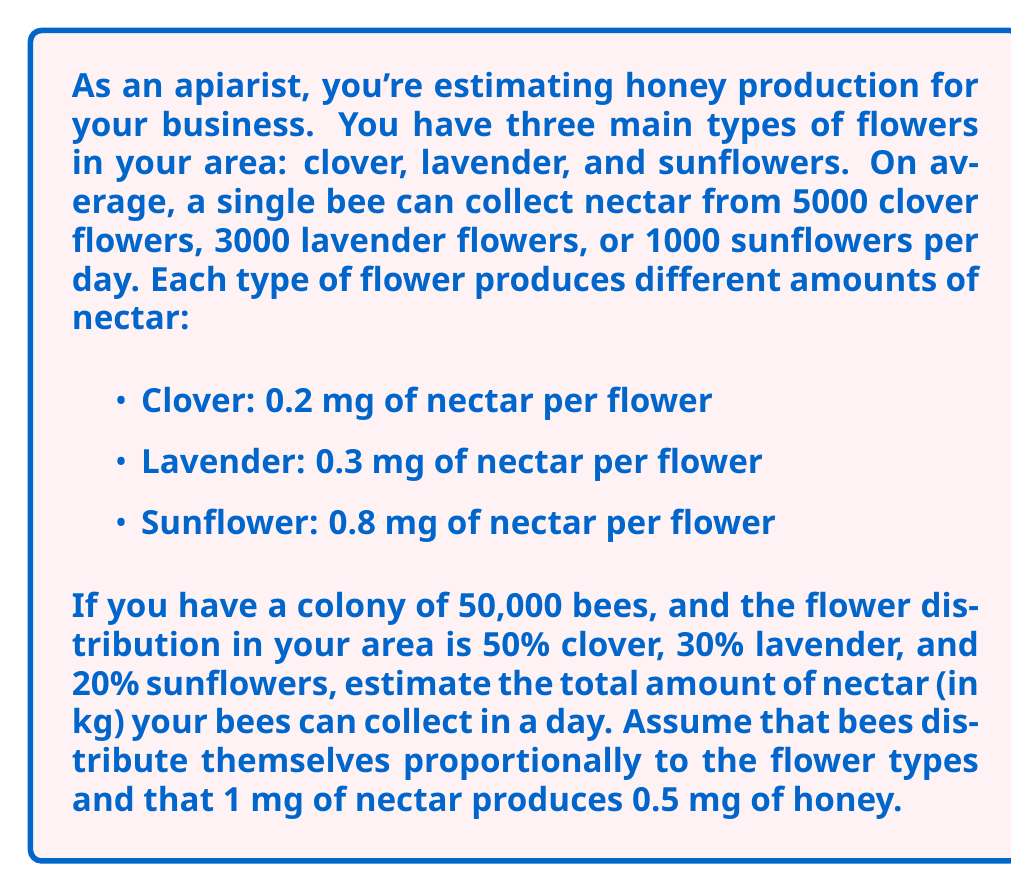Could you help me with this problem? Let's break this problem down step-by-step:

1) First, let's calculate how many bees are working on each type of flower:
   - Clover: $50,000 \times 0.50 = 25,000$ bees
   - Lavender: $50,000 \times 0.30 = 15,000$ bees
   - Sunflowers: $50,000 \times 0.20 = 10,000$ bees

2) Now, let's calculate how many flowers of each type can be visited:
   - Clover: $25,000 \times 5000 = 125,000,000$ flowers
   - Lavender: $15,000 \times 3000 = 45,000,000$ flowers
   - Sunflowers: $10,000 \times 1000 = 10,000,000$ flowers

3) Next, let's calculate the nectar collected from each type of flower:
   - Clover: $125,000,000 \times 0.2 \text{ mg} = 25,000,000 \text{ mg}$
   - Lavender: $45,000,000 \times 0.3 \text{ mg} = 13,500,000 \text{ mg}$
   - Sunflowers: $10,000,000 \times 0.8 \text{ mg} = 8,000,000 \text{ mg}$

4) The total nectar collected is the sum of these:
   $25,000,000 + 13,500,000 + 8,000,000 = 46,500,000 \text{ mg}$

5) Convert this to kg:
   $46,500,000 \text{ mg} = 46.5 \text{ kg}$

6) Finally, convert nectar to honey:
   $46.5 \text{ kg} \times 0.5 = 23.25 \text{ kg}$ of honey

Therefore, your bees can collect nectar equivalent to 23.25 kg of honey in a day.
Answer: 23.25 kg of honey 